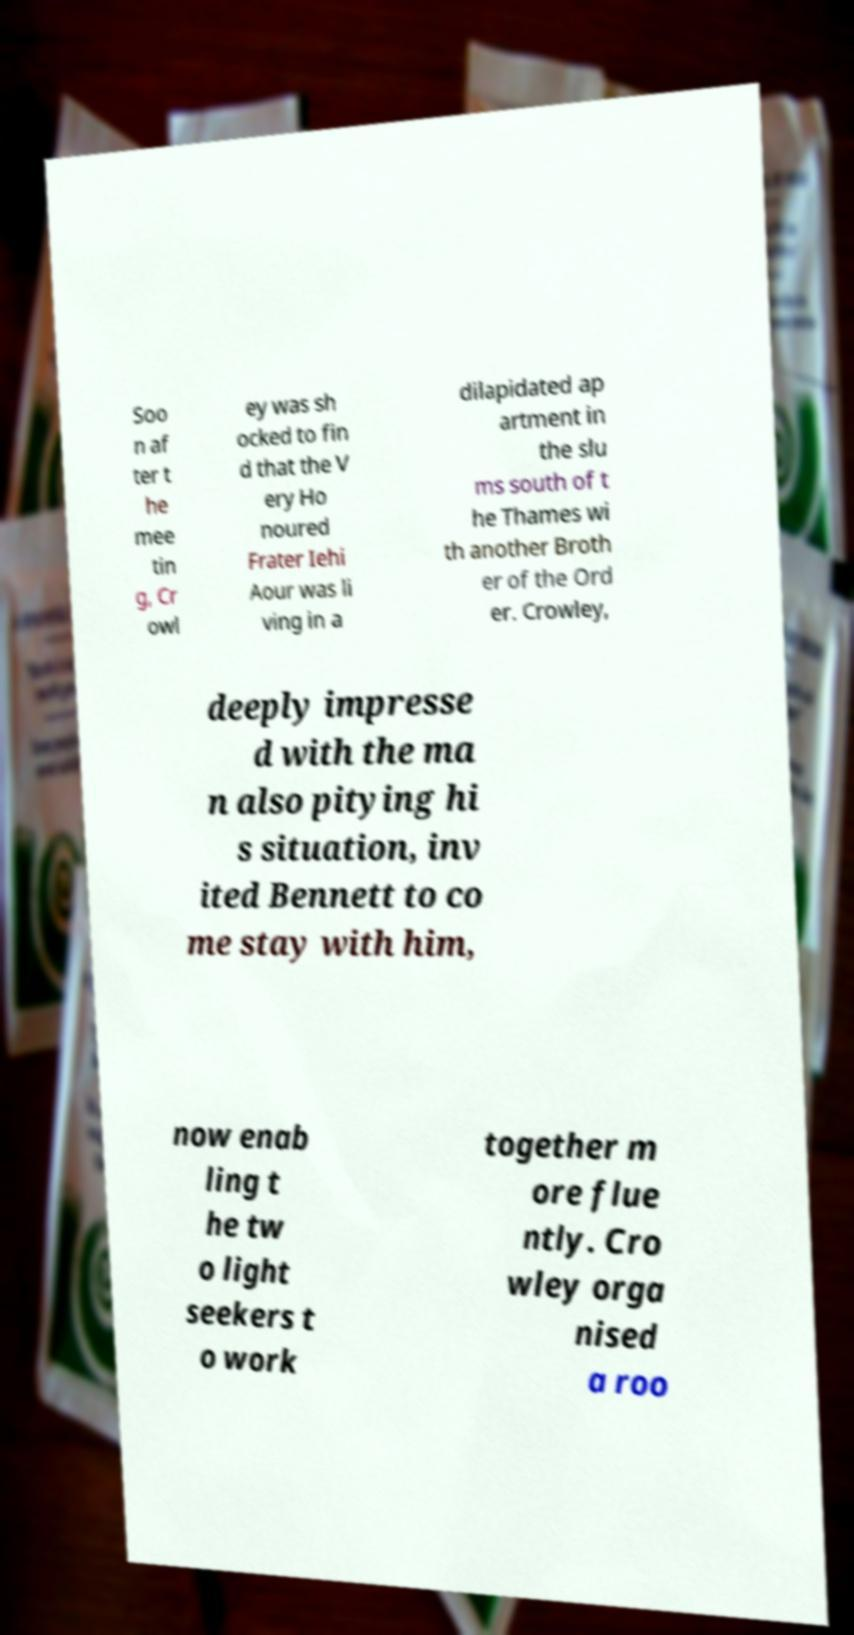I need the written content from this picture converted into text. Can you do that? Soo n af ter t he mee tin g, Cr owl ey was sh ocked to fin d that the V ery Ho noured Frater Iehi Aour was li ving in a dilapidated ap artment in the slu ms south of t he Thames wi th another Broth er of the Ord er. Crowley, deeply impresse d with the ma n also pitying hi s situation, inv ited Bennett to co me stay with him, now enab ling t he tw o light seekers t o work together m ore flue ntly. Cro wley orga nised a roo 